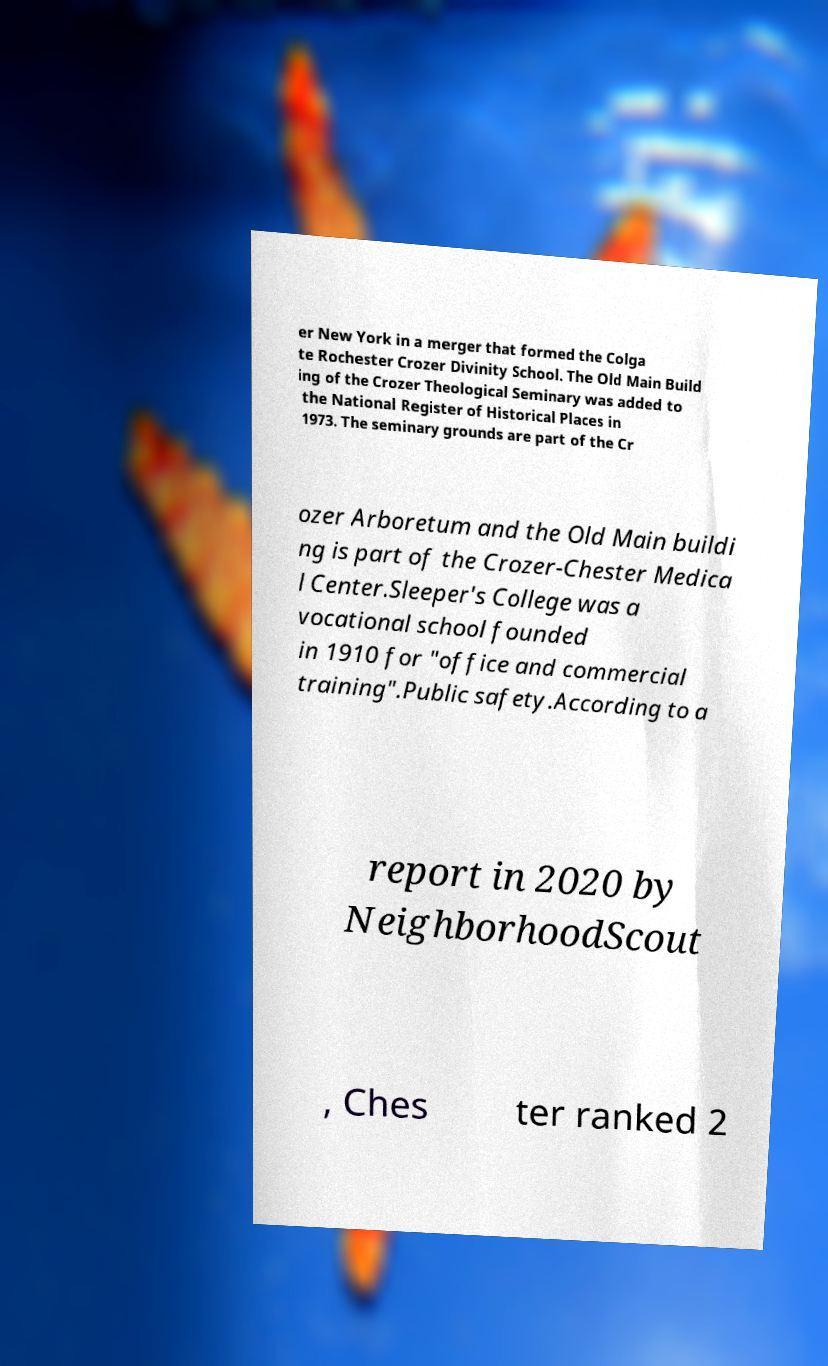What messages or text are displayed in this image? I need them in a readable, typed format. er New York in a merger that formed the Colga te Rochester Crozer Divinity School. The Old Main Build ing of the Crozer Theological Seminary was added to the National Register of Historical Places in 1973. The seminary grounds are part of the Cr ozer Arboretum and the Old Main buildi ng is part of the Crozer-Chester Medica l Center.Sleeper's College was a vocational school founded in 1910 for "office and commercial training".Public safety.According to a report in 2020 by NeighborhoodScout , Ches ter ranked 2 